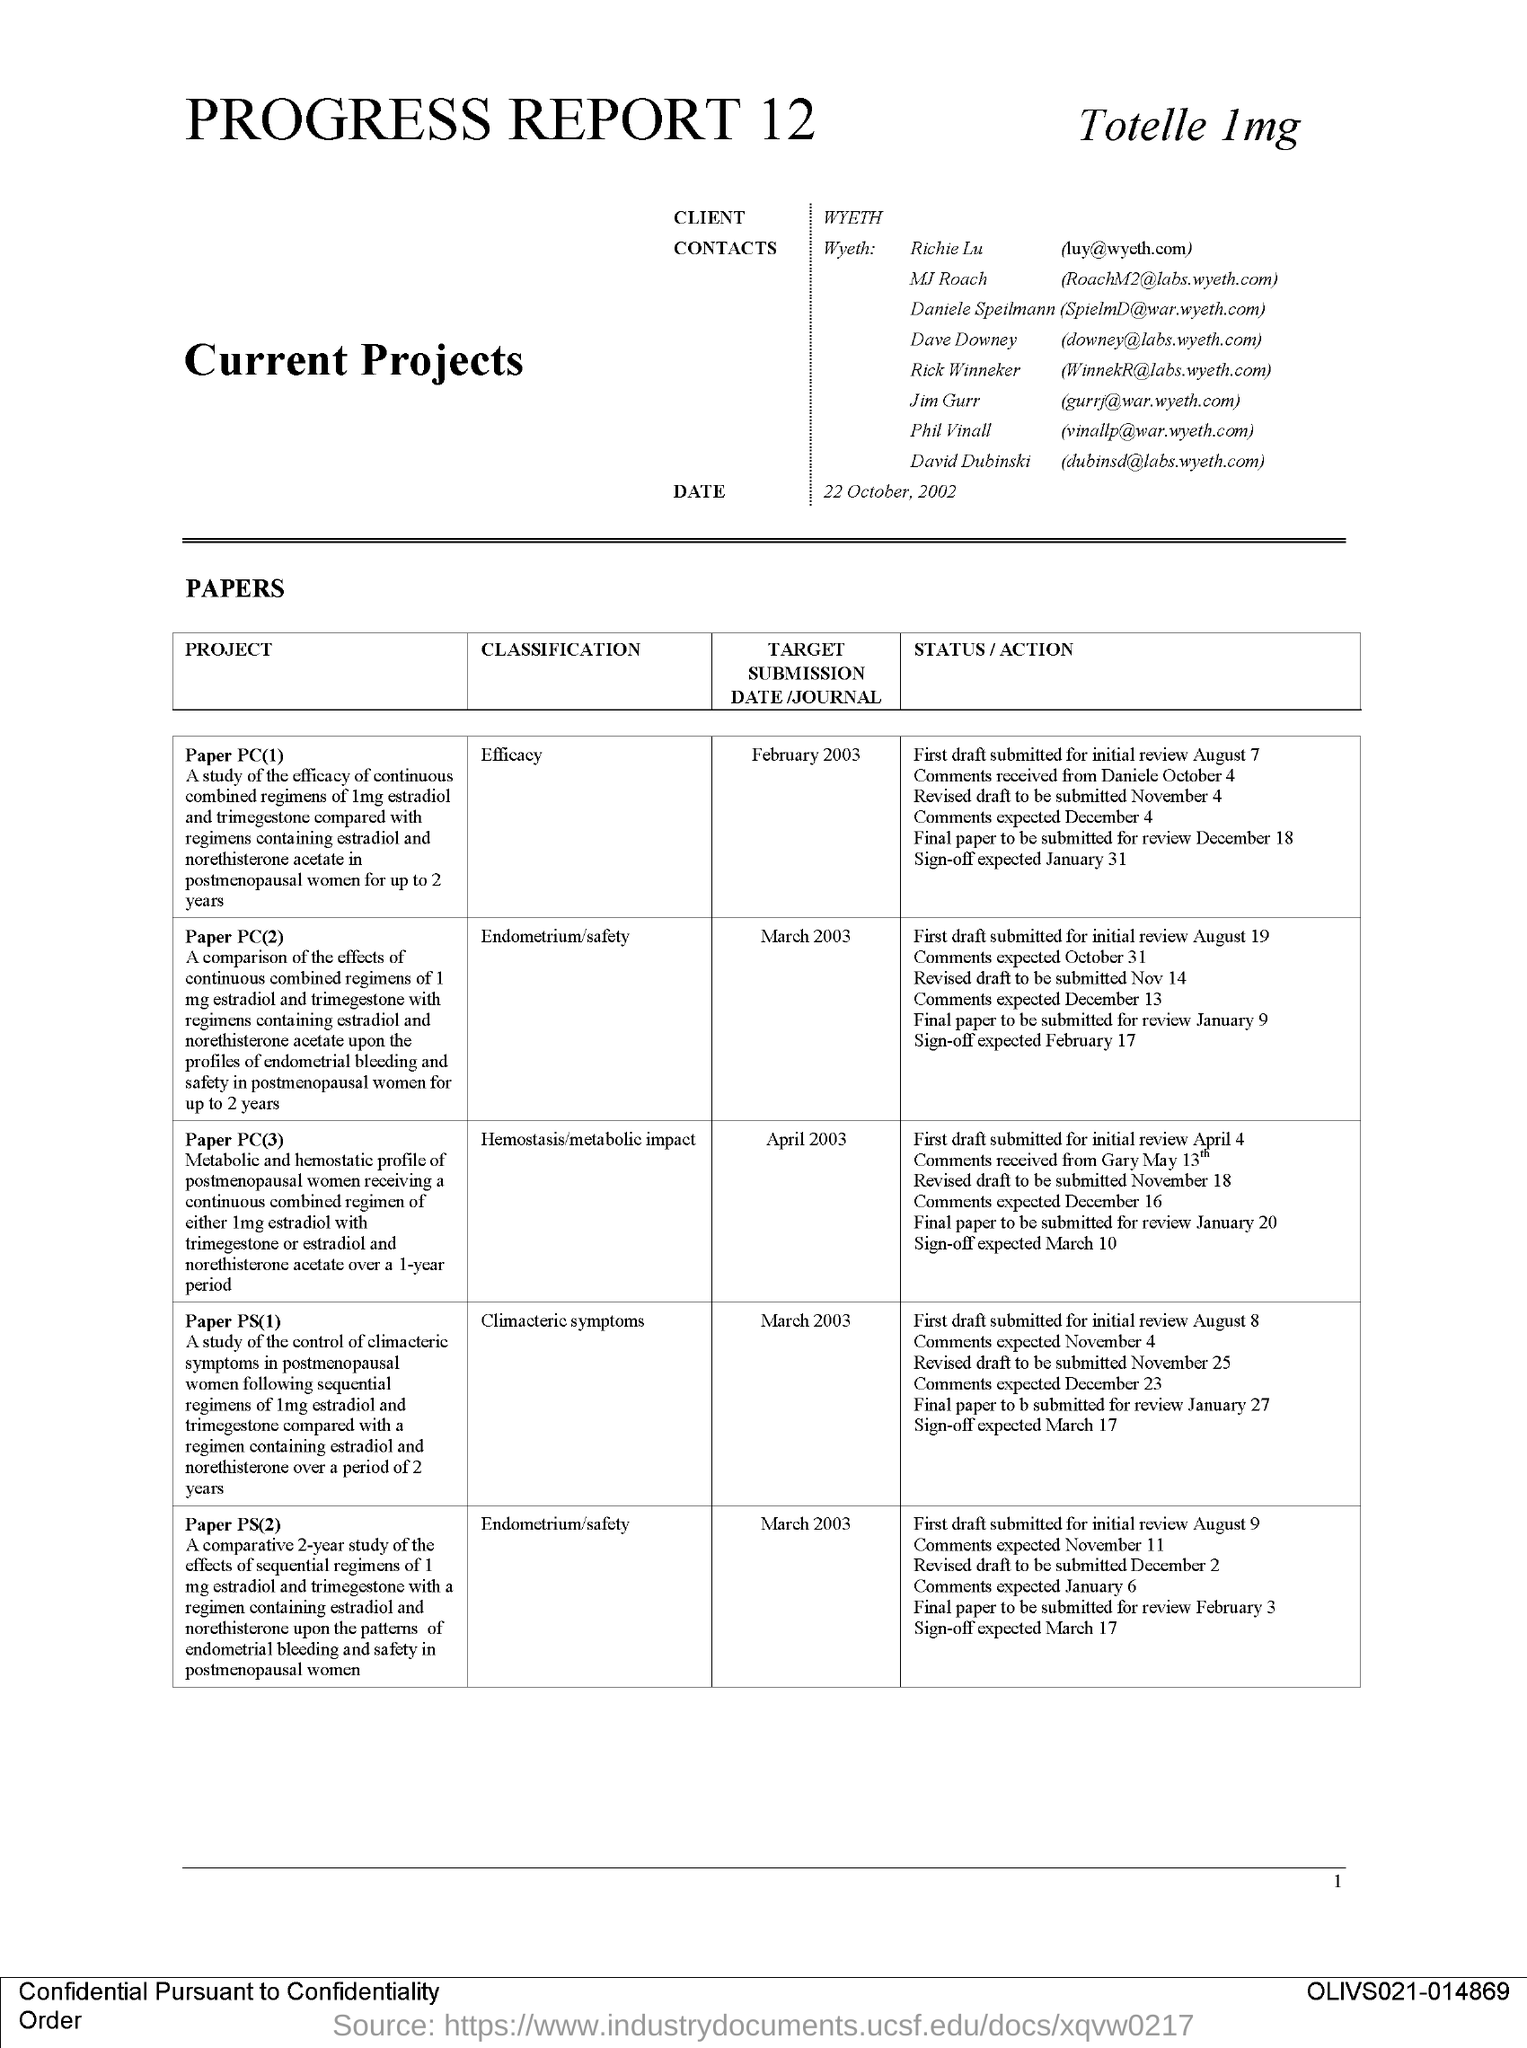What is the client name mentioned in this document?
Provide a short and direct response. Wyeth. 